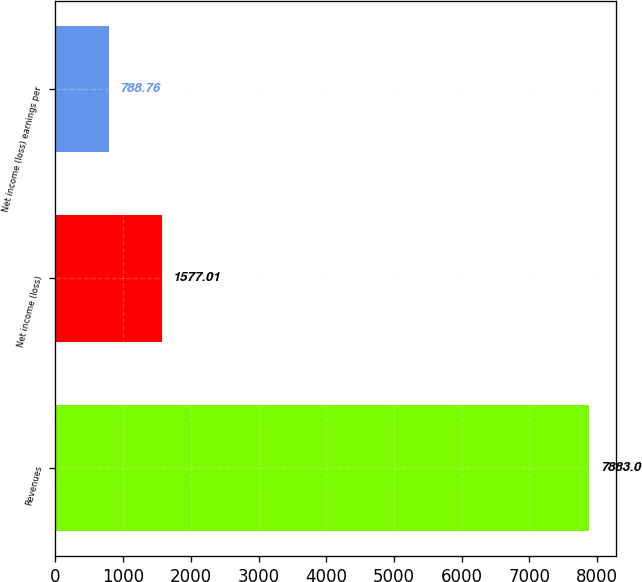<chart> <loc_0><loc_0><loc_500><loc_500><bar_chart><fcel>Revenues<fcel>Net income (loss)<fcel>Net income (loss) earnings per<nl><fcel>7883<fcel>1577.01<fcel>788.76<nl></chart> 